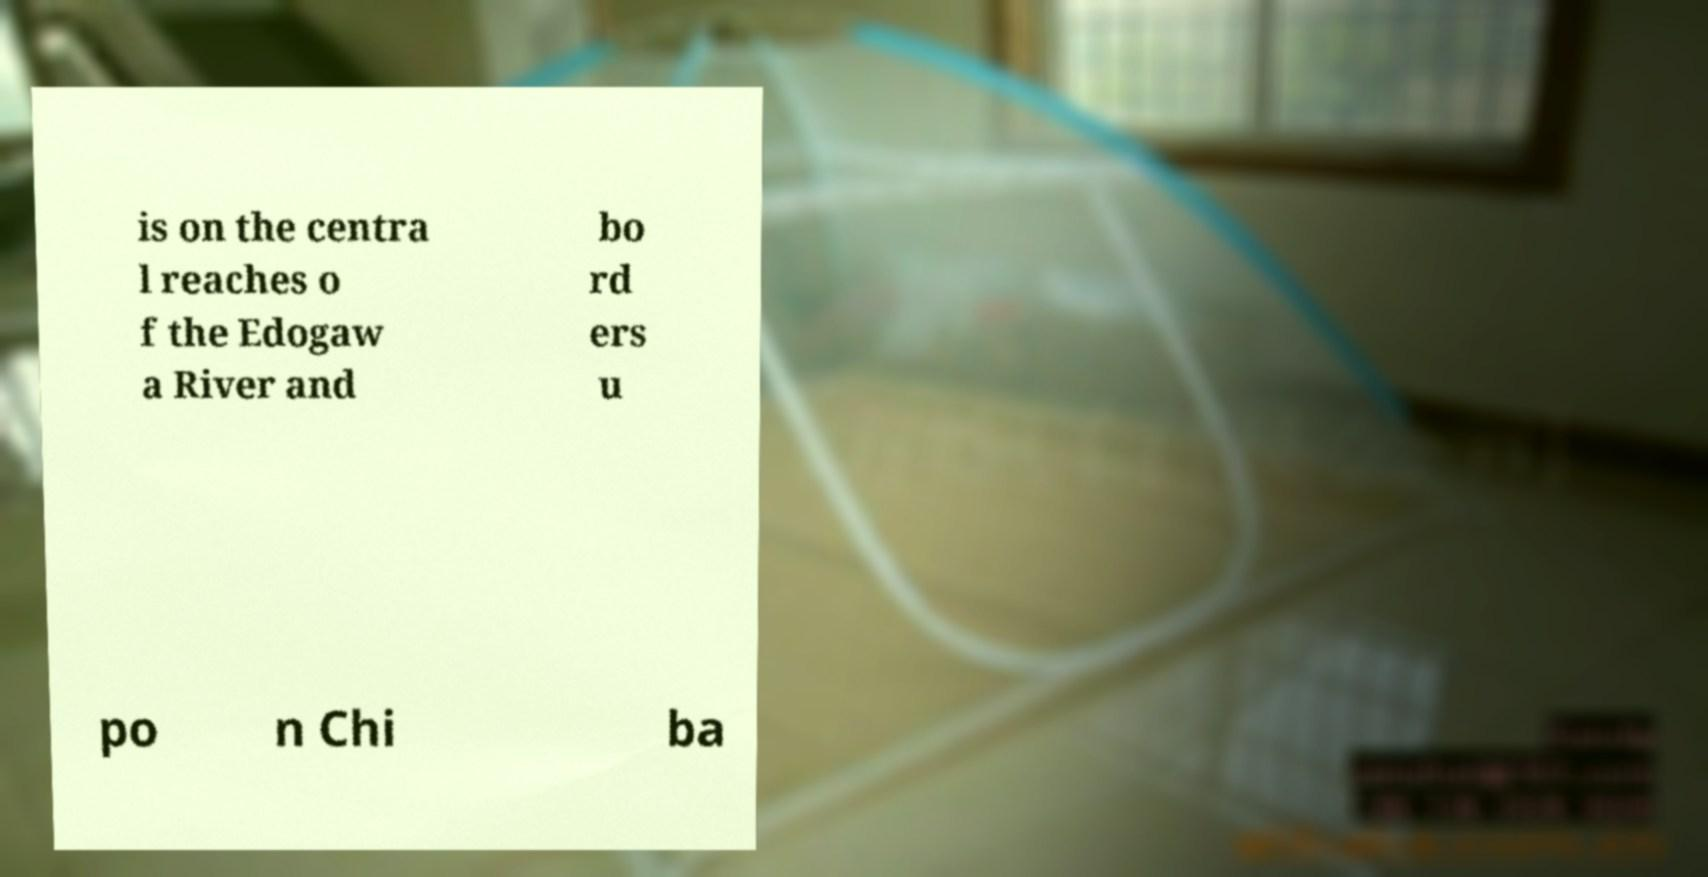What messages or text are displayed in this image? I need them in a readable, typed format. is on the centra l reaches o f the Edogaw a River and bo rd ers u po n Chi ba 